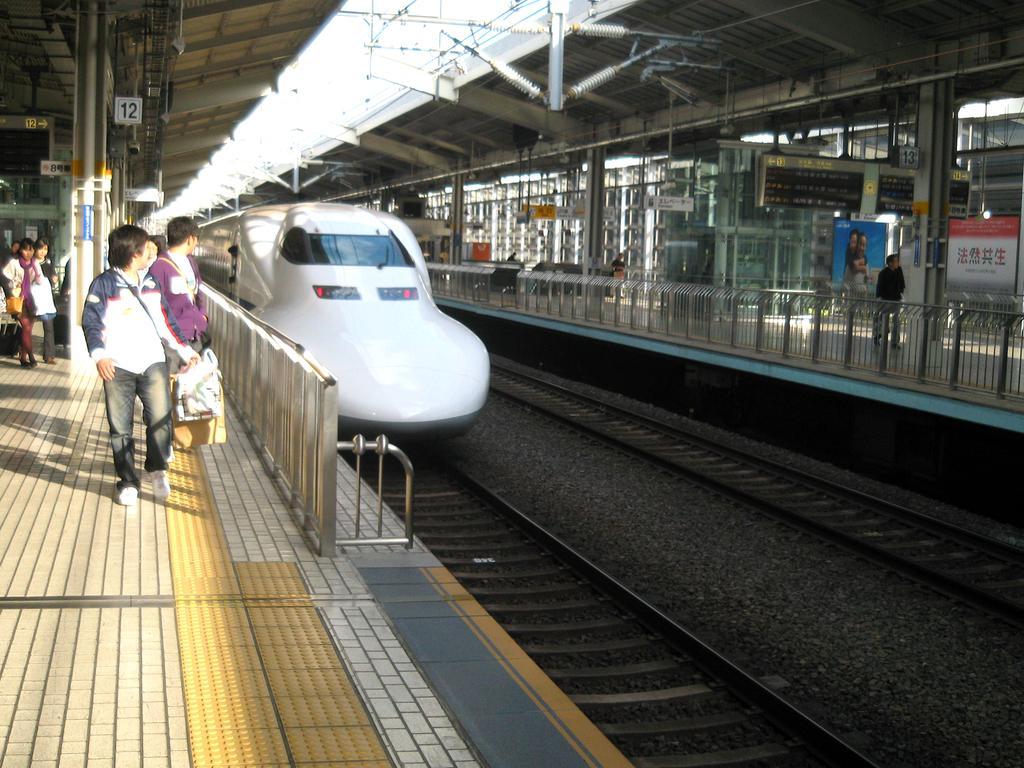Can you describe this image briefly? On the left side there is a platform with pillars and railings. Also there are many people. Near to that there are railway tracks. On that there is a train. On the right side there is a platform with pillars, railings. 